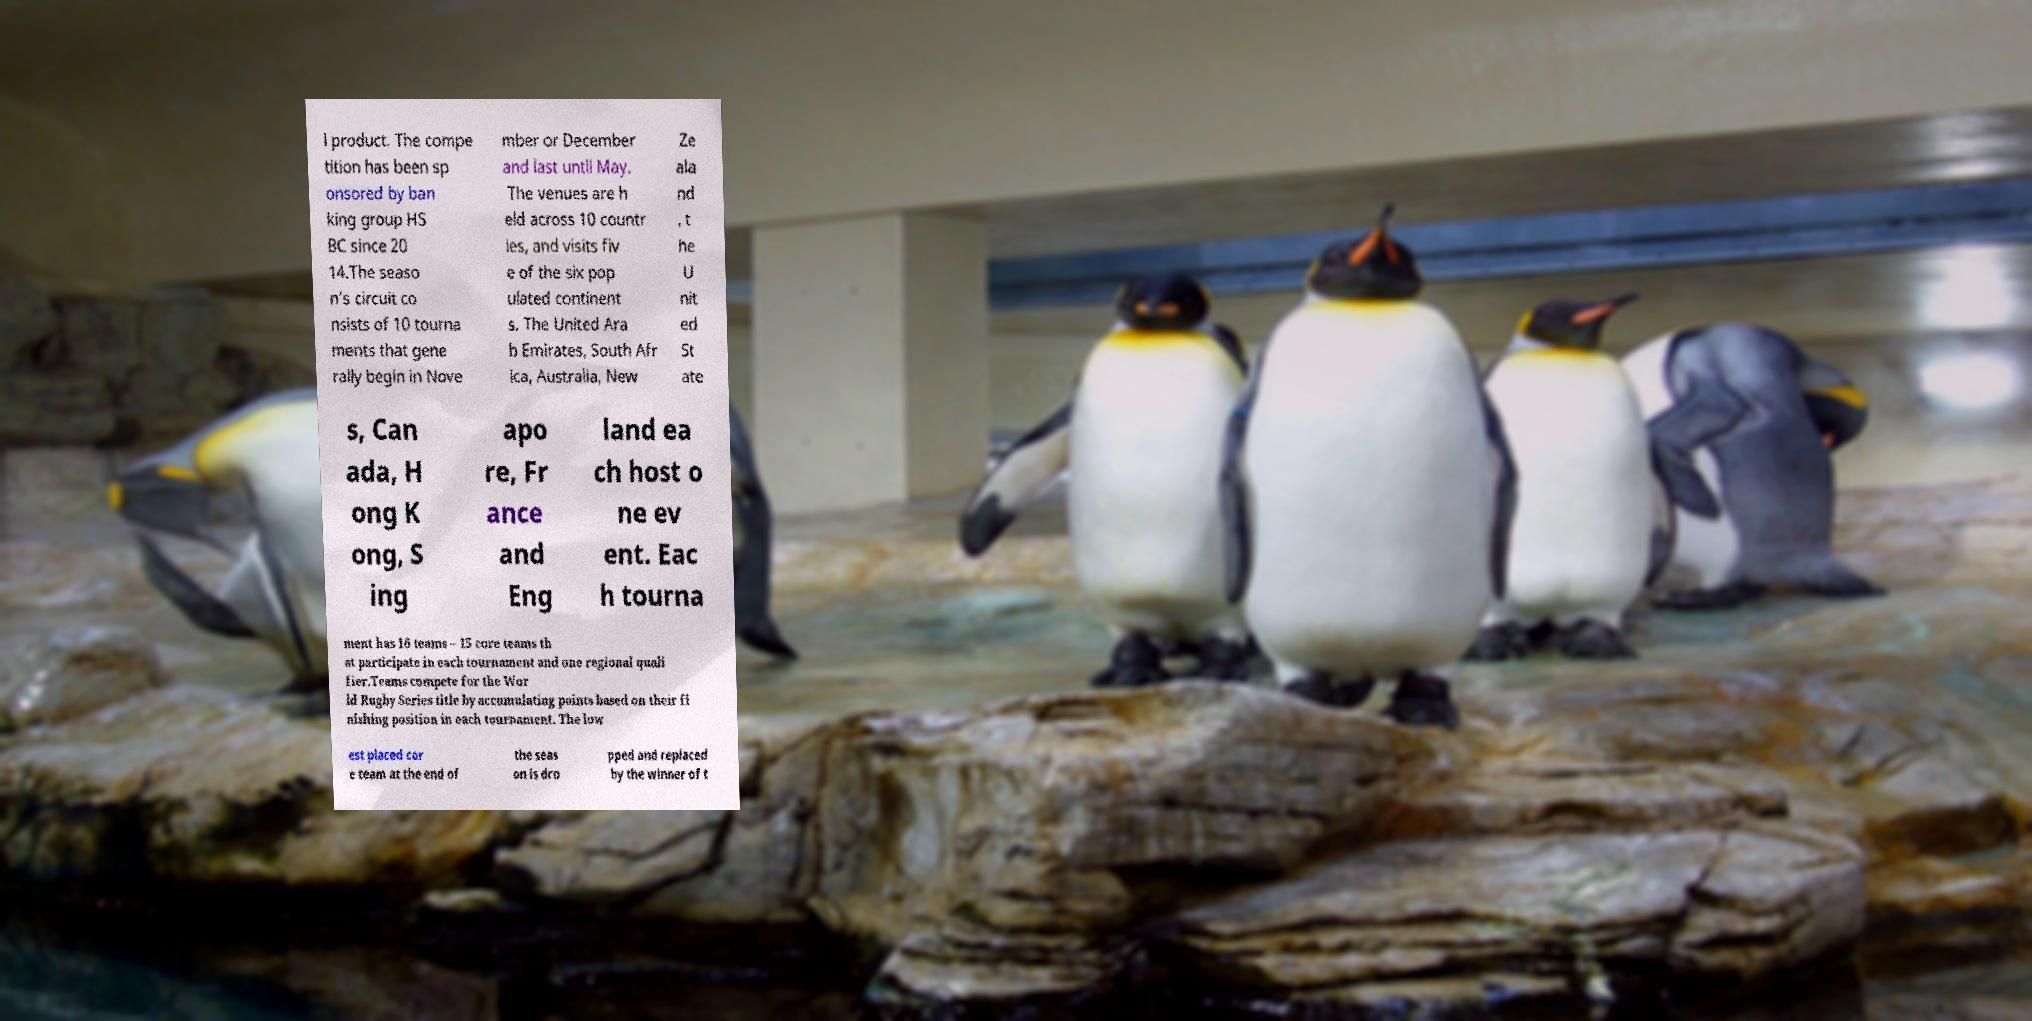What messages or text are displayed in this image? I need them in a readable, typed format. l product. The compe tition has been sp onsored by ban king group HS BC since 20 14.The seaso n's circuit co nsists of 10 tourna ments that gene rally begin in Nove mber or December and last until May. The venues are h eld across 10 countr ies, and visits fiv e of the six pop ulated continent s. The United Ara b Emirates, South Afr ica, Australia, New Ze ala nd , t he U nit ed St ate s, Can ada, H ong K ong, S ing apo re, Fr ance and Eng land ea ch host o ne ev ent. Eac h tourna ment has 16 teams – 15 core teams th at participate in each tournament and one regional quali fier.Teams compete for the Wor ld Rugby Series title by accumulating points based on their fi nishing position in each tournament. The low est placed cor e team at the end of the seas on is dro pped and replaced by the winner of t 